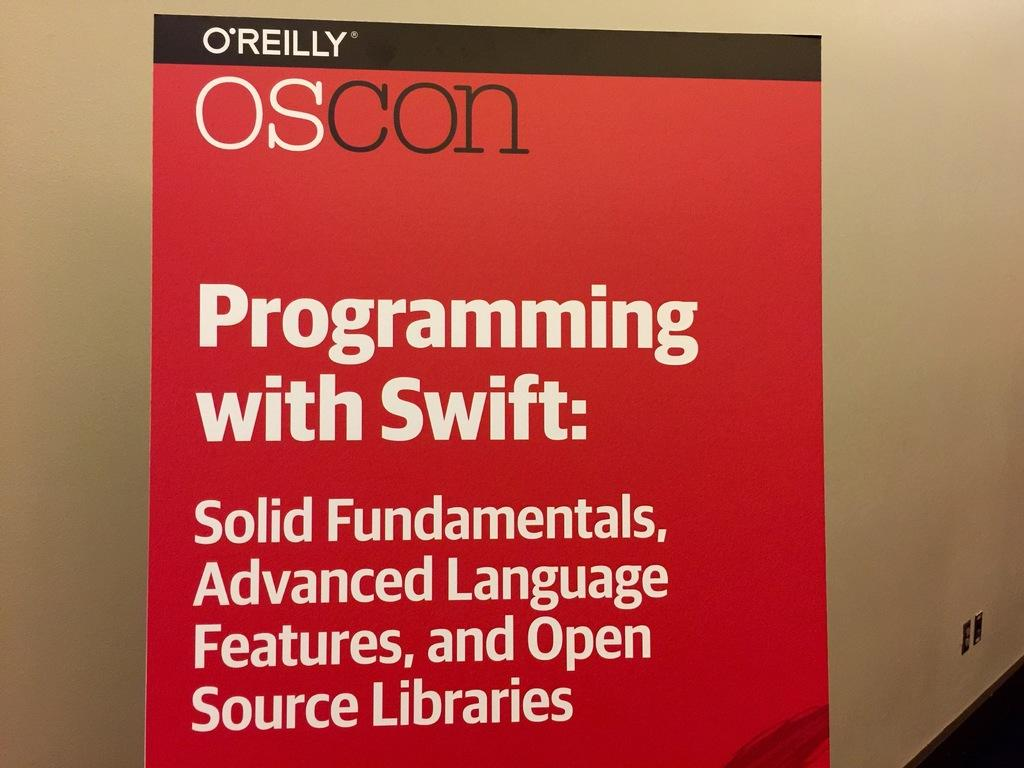Provide a one-sentence caption for the provided image. A red book cover titled Programming with Swift. 